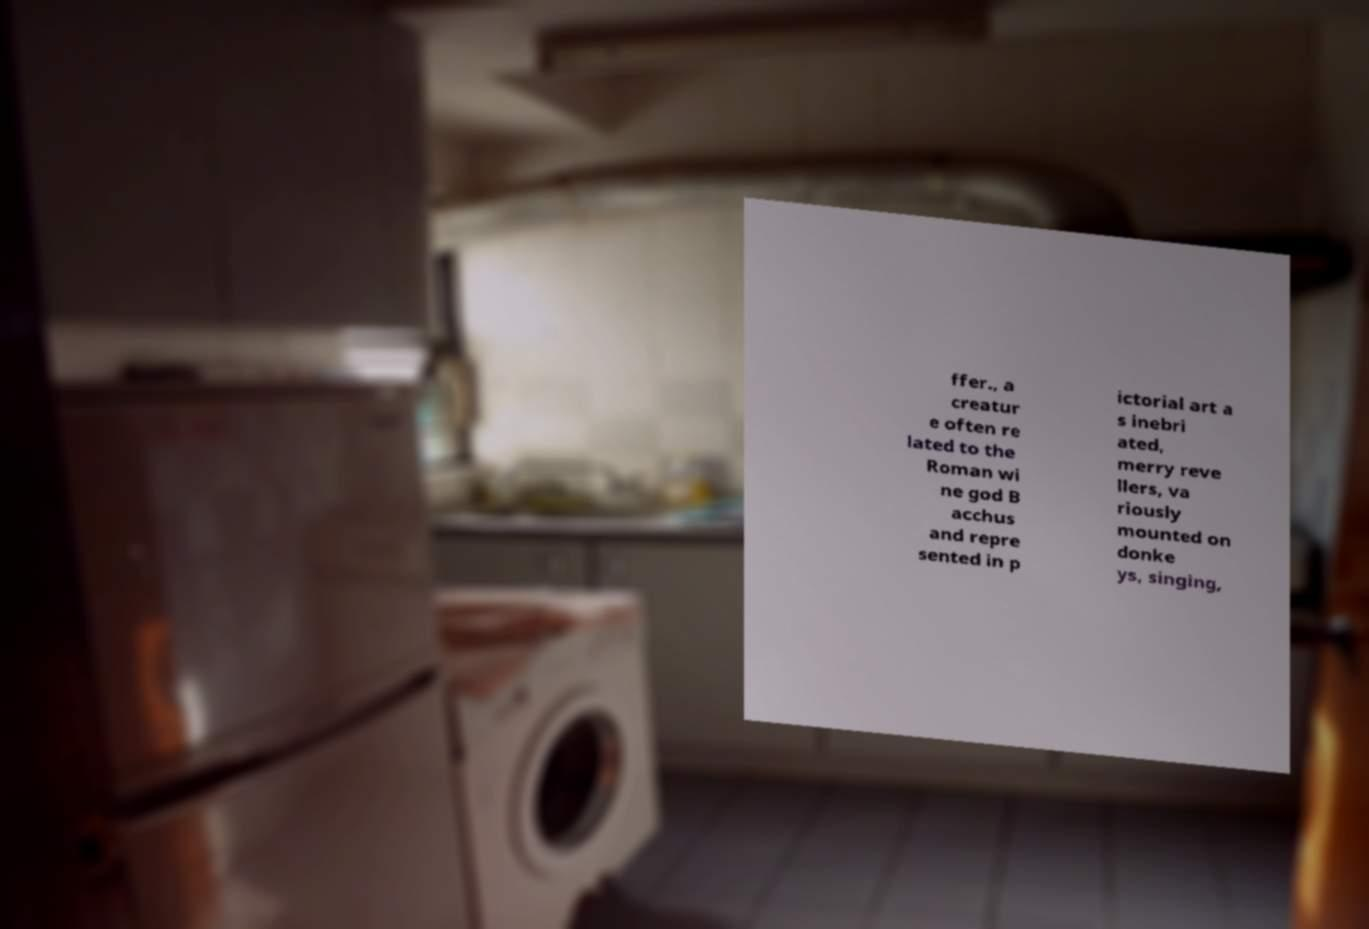What messages or text are displayed in this image? I need them in a readable, typed format. ffer., a creatur e often re lated to the Roman wi ne god B acchus and repre sented in p ictorial art a s inebri ated, merry reve llers, va riously mounted on donke ys, singing, 